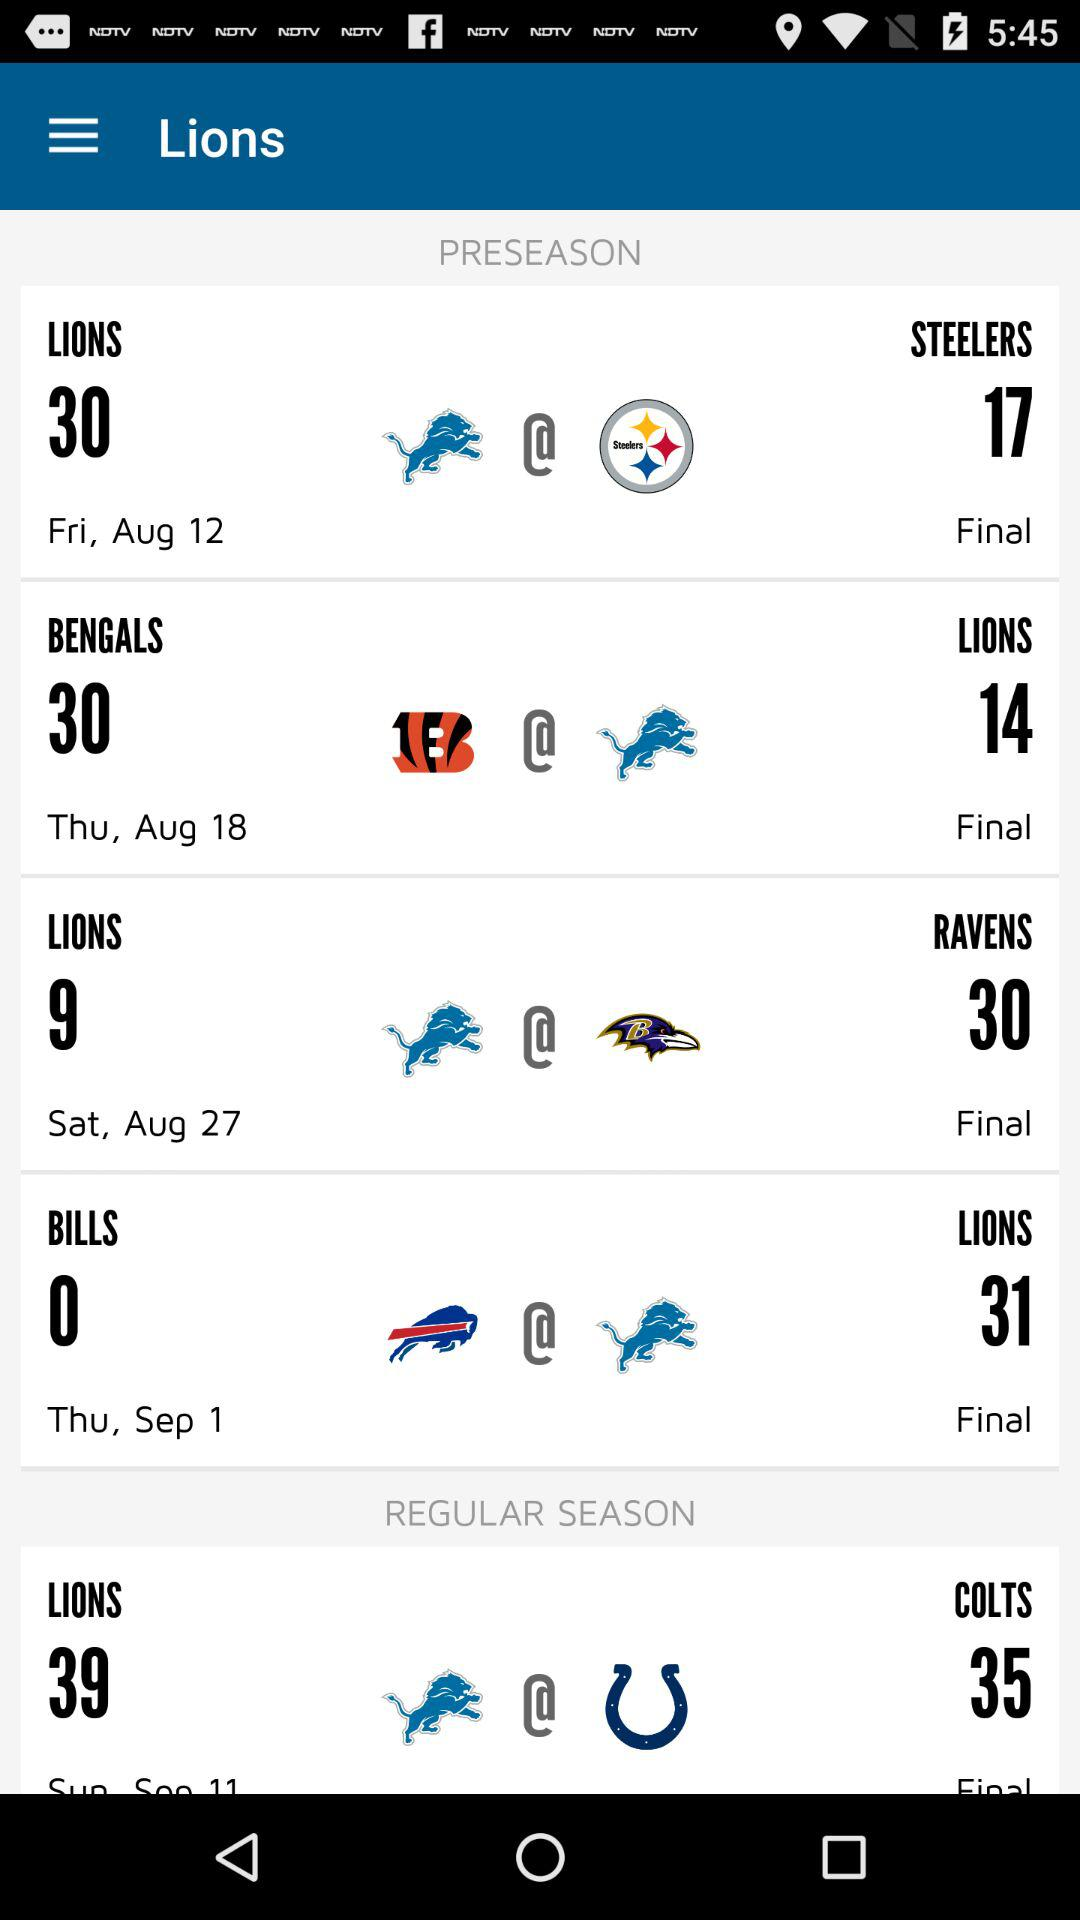In the preseason, what is the score between the "BILLS" and the "LIONS"? The score between the "BILLS" and the "LIONS" is 0 and 31. 